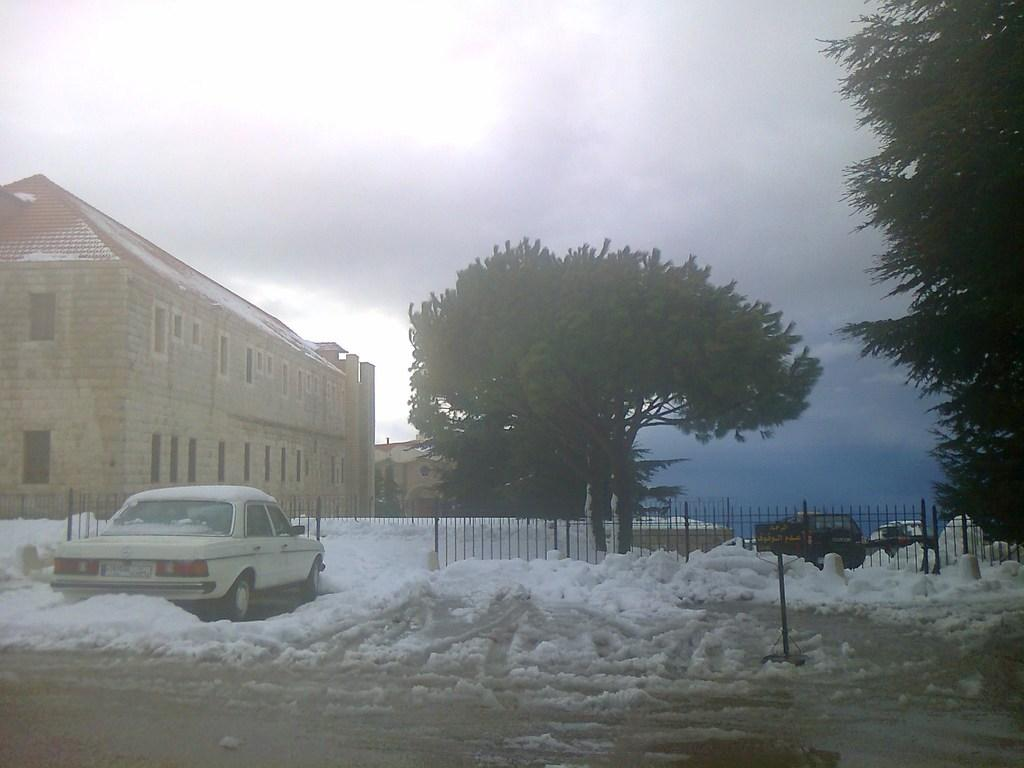What type of structures can be seen in the image? There are buildings in the image. What other natural elements are present in the image? There are trees in the image. What man-made objects can be seen in the image? There are vehicles, railings, and poles visible in the image. What is visible at the top of the image? The sky is visible at the top of the image. What type of terrain is present at the bottom of the image? Snow and sand are present at the bottom of the image. Can you hear the bells ringing in the image? There are no bells present in the image, so it is not possible to hear them ringing. 